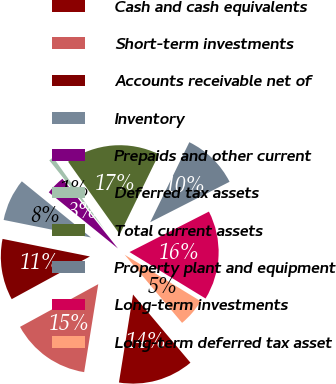<chart> <loc_0><loc_0><loc_500><loc_500><pie_chart><fcel>Cash and cash equivalents<fcel>Short-term investments<fcel>Accounts receivable net of<fcel>Inventory<fcel>Prepaids and other current<fcel>Deferred tax assets<fcel>Total current assets<fcel>Property plant and equipment<fcel>Long-term investments<fcel>Long-term deferred tax asset<nl><fcel>13.67%<fcel>14.52%<fcel>11.11%<fcel>7.7%<fcel>3.43%<fcel>0.87%<fcel>17.08%<fcel>10.26%<fcel>16.23%<fcel>5.13%<nl></chart> 